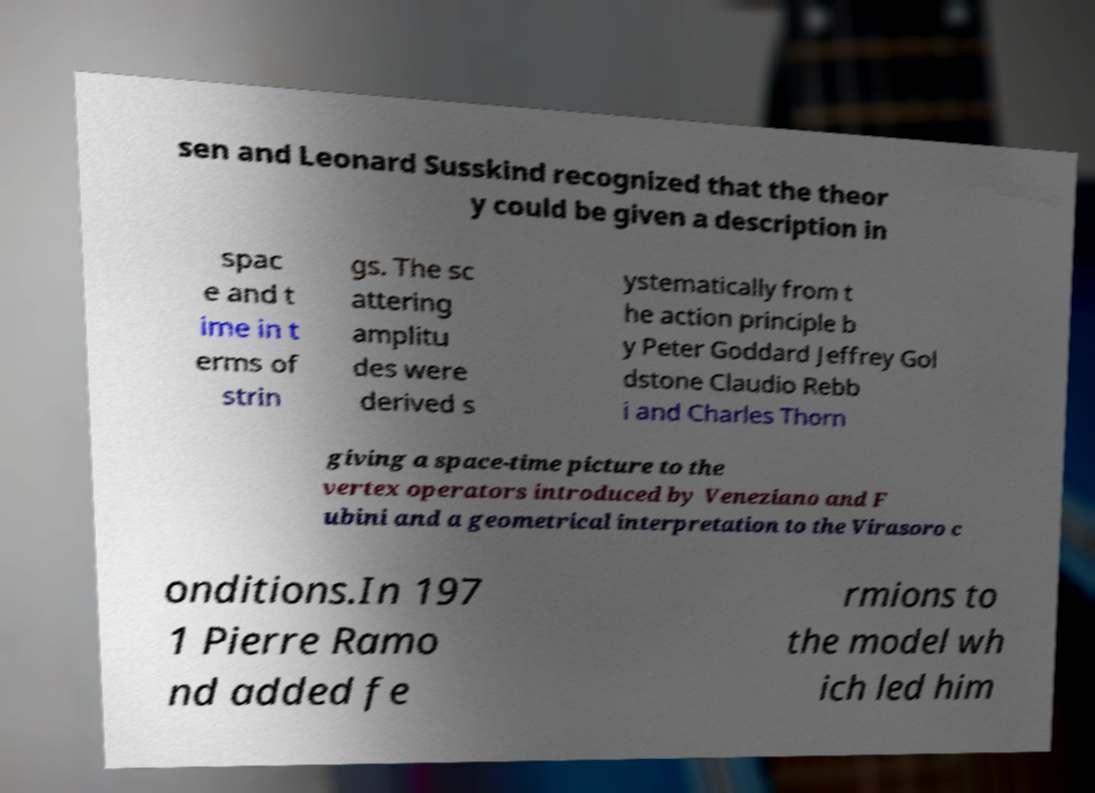There's text embedded in this image that I need extracted. Can you transcribe it verbatim? sen and Leonard Susskind recognized that the theor y could be given a description in spac e and t ime in t erms of strin gs. The sc attering amplitu des were derived s ystematically from t he action principle b y Peter Goddard Jeffrey Gol dstone Claudio Rebb i and Charles Thorn giving a space-time picture to the vertex operators introduced by Veneziano and F ubini and a geometrical interpretation to the Virasoro c onditions.In 197 1 Pierre Ramo nd added fe rmions to the model wh ich led him 